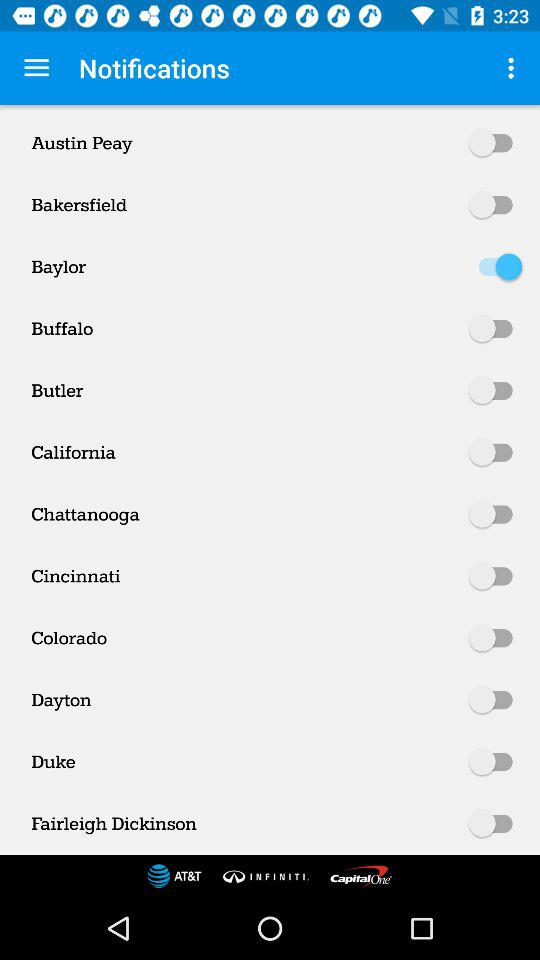What is the current state of Dayton? The current state is "off". 